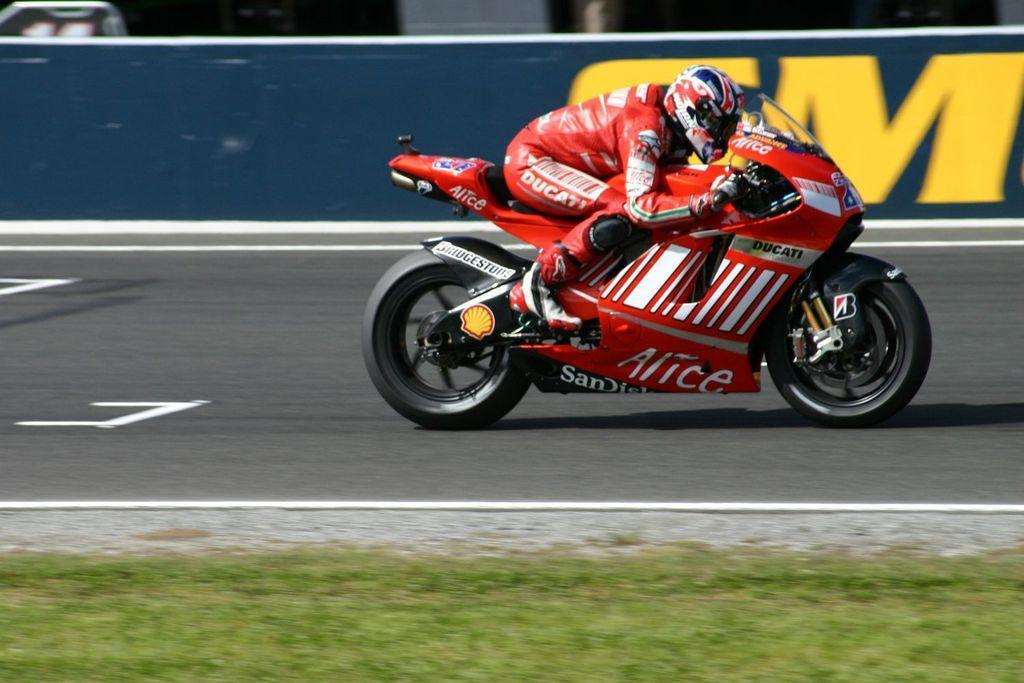How would you summarize this image in a sentence or two? In this image I can see the person riding the bike, the person is wearing red color dress and the bike is in white and red color. In the background I can see the board in blue color. 